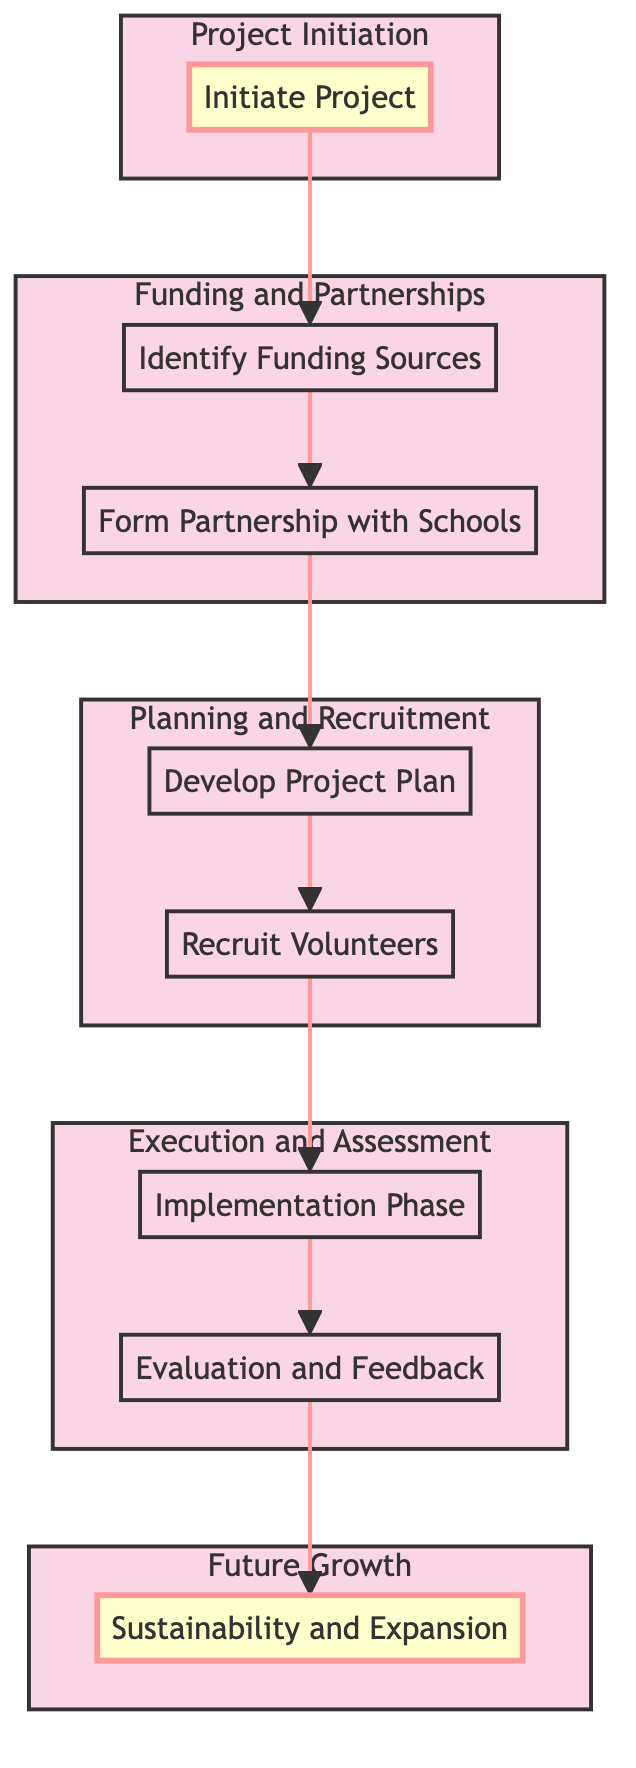What is the main goal of the project? The diagram specifies that the main goal of the project is to "Enhance learning through collaborative art," which is stated in the "Initiate Project" node.
Answer: Enhance learning through collaborative art How many key objectives are listed under the "Initiate Project"? The "Initiate Project" node includes three key objectives: "Foster creativity," "Build teamwork skills," and "Provide a therapeutic outlet," making the total count three.
Answer: 3 What comes immediately after identifying funding sources? The flow of the diagram indicates that after "Identify Funding Sources," the next step is "Form Partnership with Schools."
Answer: Form Partnership with Schools Which phase includes the "Weekly Sessions"? According to the diagram, "Weekly Sessions" is part of the "Implementation Phase," which follows the "Recruit Volunteers" step.
Answer: Implementation Phase What actions are mentioned under "Evaluate and Feedback"? The actions listed under "Evaluation and Feedback" include "Student Assessments," "Teacher Feedback," and "Community Reviews," showcasing various ways to measure the project's impact.
Answer: Student Assessments, Teacher Feedback, Community Reviews What is the last phase of the project depicted in the diagram? The final phase present in the flow chart is "Sustainability and Expansion," which is the last node at the top of the diagram.
Answer: Sustainability and Expansion How many subgroups are outlined in the diagram? The diagram categorizes the project into five distinct subgroups: "Project Initiation," "Funding and Partnerships," "Planning and Recruitment," "Execution and Assessment," and "Future Growth," totaling five subgroups.
Answer: 5 What is the first action listed in the "Develop Project Plan"? The first action mentioned in the "Develop Project Plan" is "Curriculum Creation," indicating where the planning begins within that phase.
Answer: Curriculum Creation Which funding source is categorized under "Crowdfunding"? Under the "Identify Funding Sources" section, "Kickstarter" and "GoFundMe" are the two options specified as crowdfunding sources.
Answer: Kickstarter, GoFundMe 